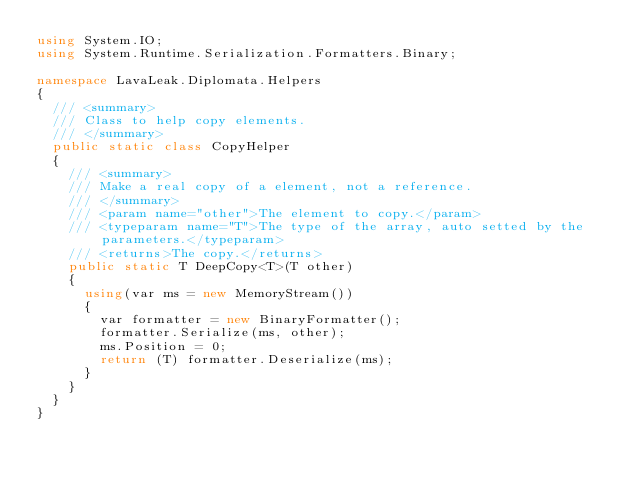Convert code to text. <code><loc_0><loc_0><loc_500><loc_500><_C#_>using System.IO;
using System.Runtime.Serialization.Formatters.Binary;

namespace LavaLeak.Diplomata.Helpers
{
  /// <summary>
  /// Class to help copy elements.
  /// </summary>
  public static class CopyHelper
  {
    /// <summary>
    /// Make a real copy of a element, not a reference.
    /// </summary>
    /// <param name="other">The element to copy.</param>
    /// <typeparam name="T">The type of the array, auto setted by the parameters.</typeparam>
    /// <returns>The copy.</returns>
    public static T DeepCopy<T>(T other)
    {
      using(var ms = new MemoryStream())
      {
        var formatter = new BinaryFormatter();
        formatter.Serialize(ms, other);
        ms.Position = 0;
        return (T) formatter.Deserialize(ms);
      }
    }
  }
}</code> 